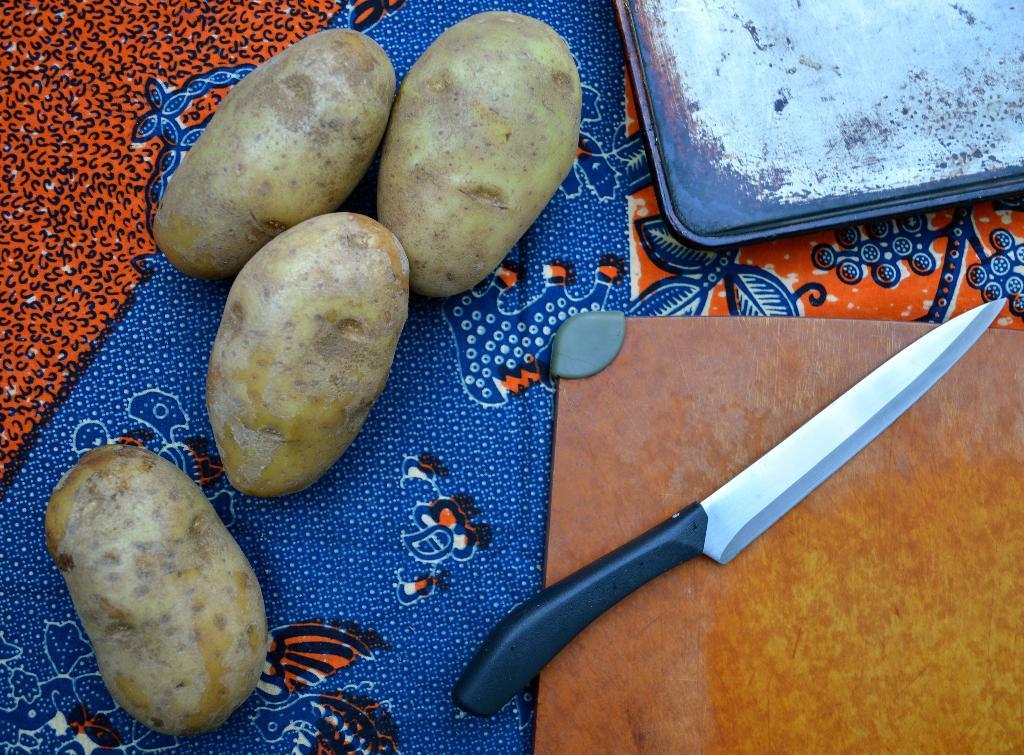Can you describe this image briefly? The picture consists of potatoes, knife, boards on a cloth. 